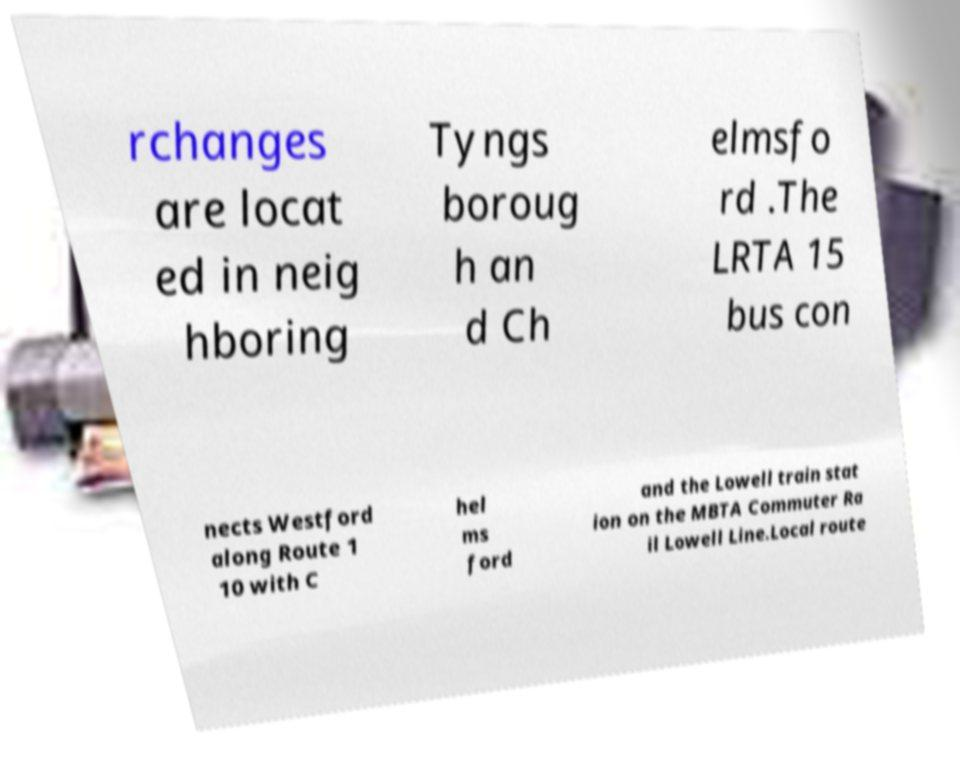I need the written content from this picture converted into text. Can you do that? rchanges are locat ed in neig hboring Tyngs boroug h an d Ch elmsfo rd .The LRTA 15 bus con nects Westford along Route 1 10 with C hel ms ford and the Lowell train stat ion on the MBTA Commuter Ra il Lowell Line.Local route 